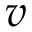Convert formula to latex. <formula><loc_0><loc_0><loc_500><loc_500>v</formula> 